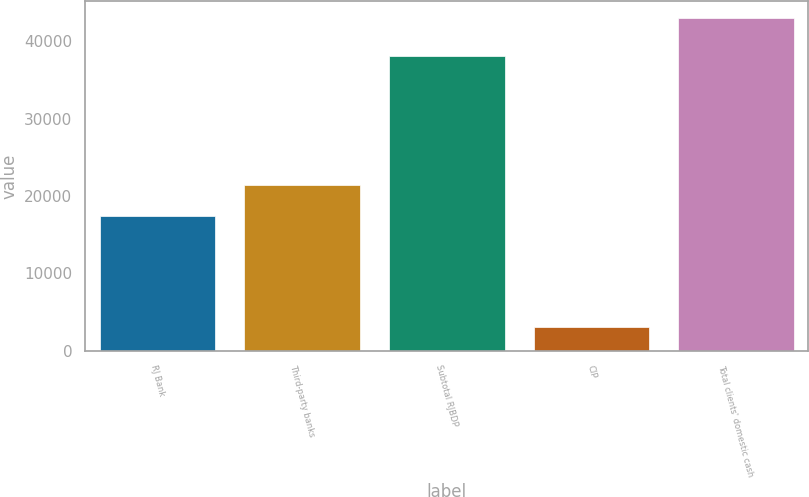Convert chart. <chart><loc_0><loc_0><loc_500><loc_500><bar_chart><fcel>RJ Bank<fcel>Third-party banks<fcel>Subtotal RJBDP<fcel>CIP<fcel>Total clients' domestic cash<nl><fcel>17387<fcel>21377.9<fcel>38091<fcel>3101<fcel>43010<nl></chart> 